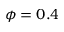<formula> <loc_0><loc_0><loc_500><loc_500>\phi = 0 . 4</formula> 